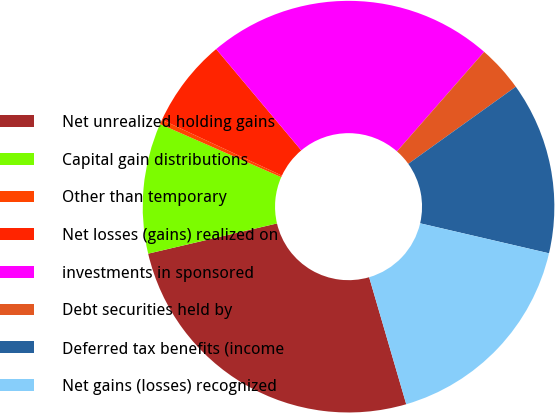Convert chart to OTSL. <chart><loc_0><loc_0><loc_500><loc_500><pie_chart><fcel>Net unrealized holding gains<fcel>Capital gain distributions<fcel>Other than temporary<fcel>Net losses (gains) realized on<fcel>investments in sponsored<fcel>Debt securities held by<fcel>Deferred tax benefits (income<fcel>Net gains (losses) recognized<nl><fcel>25.86%<fcel>10.24%<fcel>0.36%<fcel>6.95%<fcel>22.57%<fcel>3.65%<fcel>13.54%<fcel>16.84%<nl></chart> 